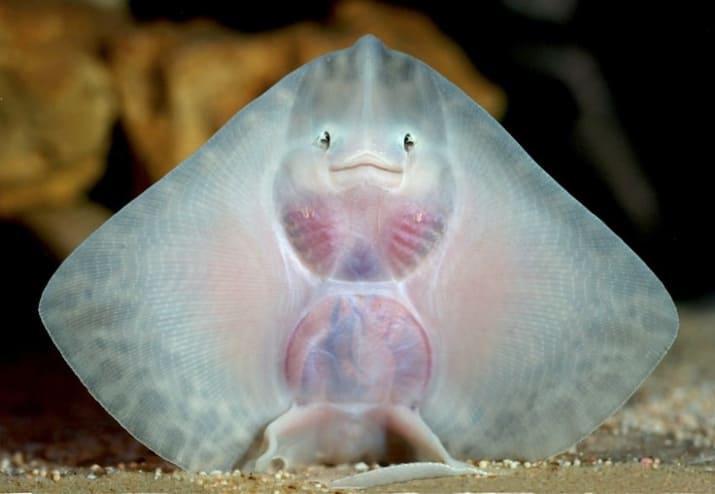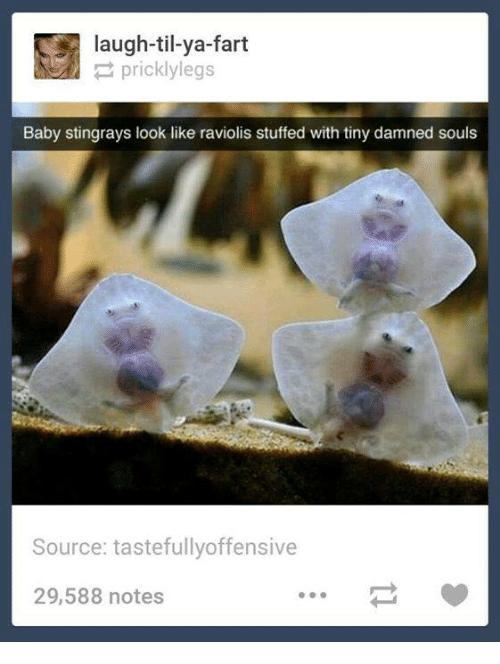The first image is the image on the left, the second image is the image on the right. Examine the images to the left and right. Is the description "The left image contains just one stingray." accurate? Answer yes or no. Yes. The first image is the image on the left, the second image is the image on the right. Assess this claim about the two images: "The left and right image contains a total of five stingrays.". Correct or not? Answer yes or no. No. 